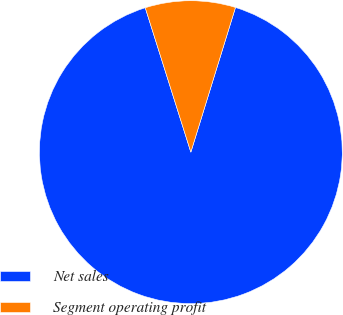Convert chart. <chart><loc_0><loc_0><loc_500><loc_500><pie_chart><fcel>Net sales<fcel>Segment operating profit<nl><fcel>90.37%<fcel>9.63%<nl></chart> 